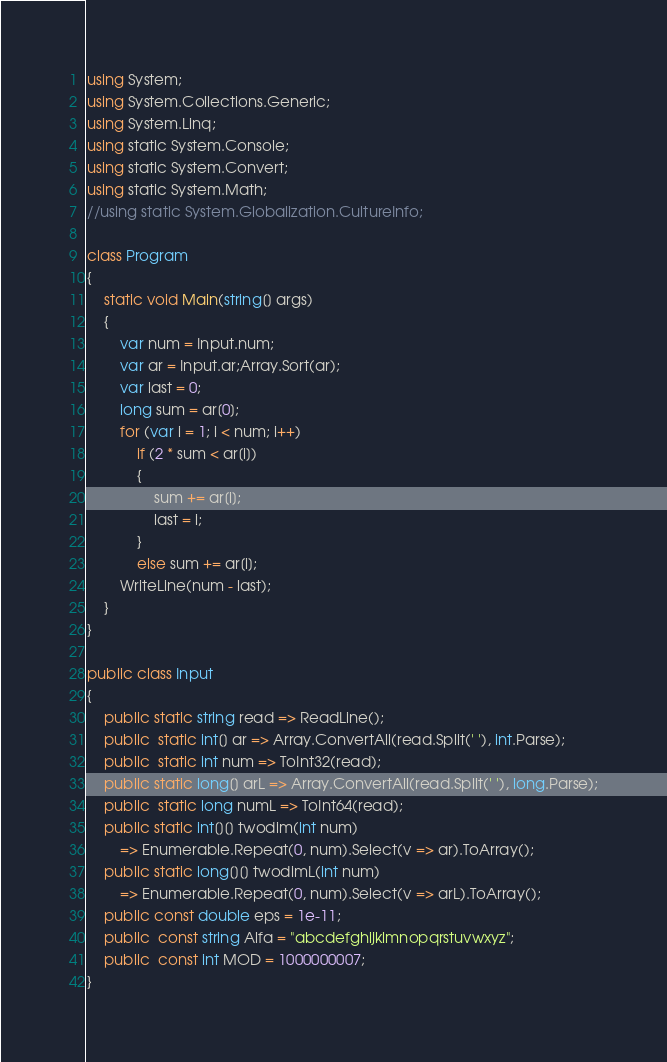<code> <loc_0><loc_0><loc_500><loc_500><_C#_>using System;
using System.Collections.Generic;
using System.Linq;
using static System.Console;
using static System.Convert;
using static System.Math;
//using static System.Globalization.CultureInfo;

class Program
{ 
    static void Main(string[] args)
    {
        var num = Input.num;
        var ar = Input.ar;Array.Sort(ar);
        var last = 0;
        long sum = ar[0];
        for (var i = 1; i < num; i++)
            if (2 * sum < ar[i])
            {
                sum += ar[i];
                last = i;
            }
            else sum += ar[i];
        WriteLine(num - last);
    }
}

public class Input
{
    public static string read => ReadLine();
    public  static int[] ar => Array.ConvertAll(read.Split(' '), int.Parse);
    public  static int num => ToInt32(read);
    public static long[] arL => Array.ConvertAll(read.Split(' '), long.Parse);
    public  static long numL => ToInt64(read);
    public static int[][] twodim(int num)
        => Enumerable.Repeat(0, num).Select(v => ar).ToArray();
    public static long[][] twodimL(int num)
        => Enumerable.Repeat(0, num).Select(v => arL).ToArray();
    public const double eps = 1e-11;
    public  const string Alfa = "abcdefghijklmnopqrstuvwxyz";
    public  const int MOD = 1000000007;
}
</code> 